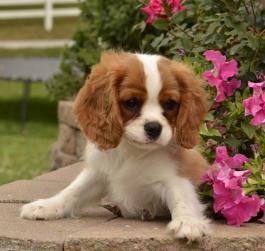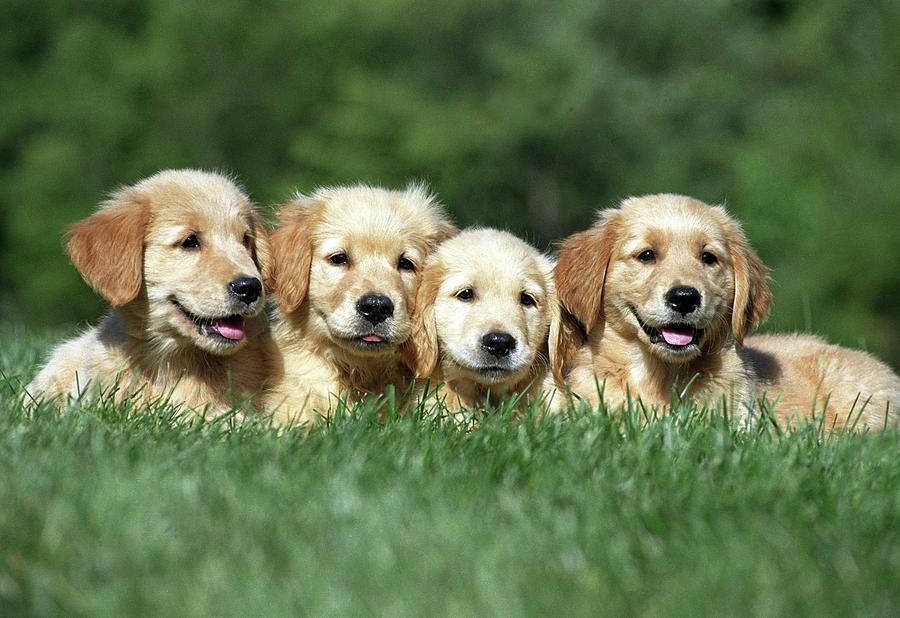The first image is the image on the left, the second image is the image on the right. Evaluate the accuracy of this statement regarding the images: "There are at most 2 puppies.". Is it true? Answer yes or no. No. The first image is the image on the left, the second image is the image on the right. Analyze the images presented: Is the assertion "There are no more than two puppies." valid? Answer yes or no. No. 